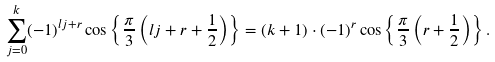<formula> <loc_0><loc_0><loc_500><loc_500>\sum _ { j = 0 } ^ { k } ( - 1 ) ^ { l j + r } \cos \left \{ \frac { \pi } { 3 } \left ( l j + r + \frac { 1 } { 2 } \right ) \right \} = ( k + 1 ) \cdot ( - 1 ) ^ { r } \cos \left \{ \frac { \pi } { 3 } \left ( r + \frac { 1 } { 2 } \right ) \right \} .</formula> 